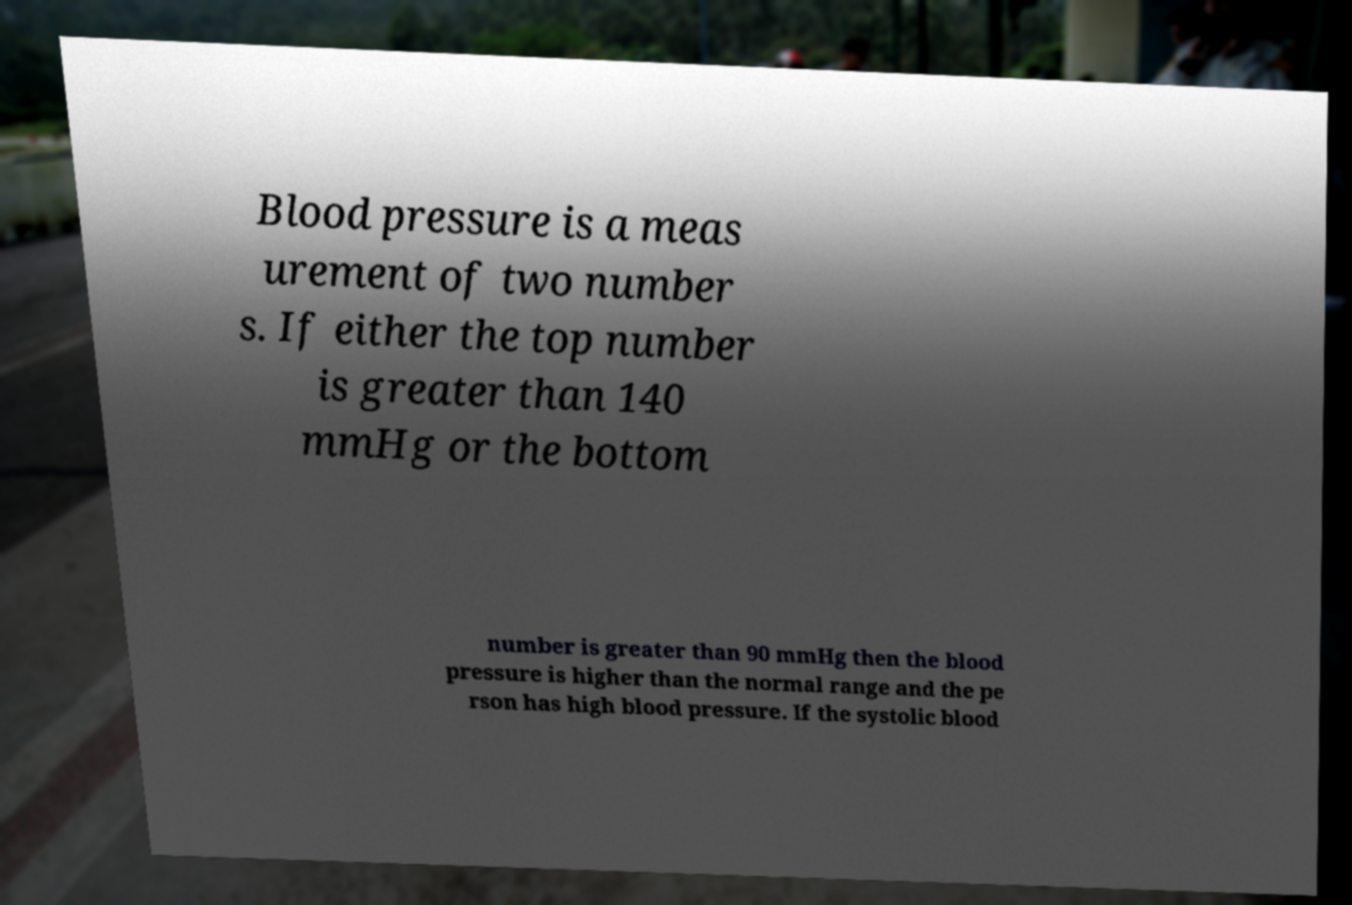Please read and relay the text visible in this image. What does it say? Blood pressure is a meas urement of two number s. If either the top number is greater than 140 mmHg or the bottom number is greater than 90 mmHg then the blood pressure is higher than the normal range and the pe rson has high blood pressure. If the systolic blood 